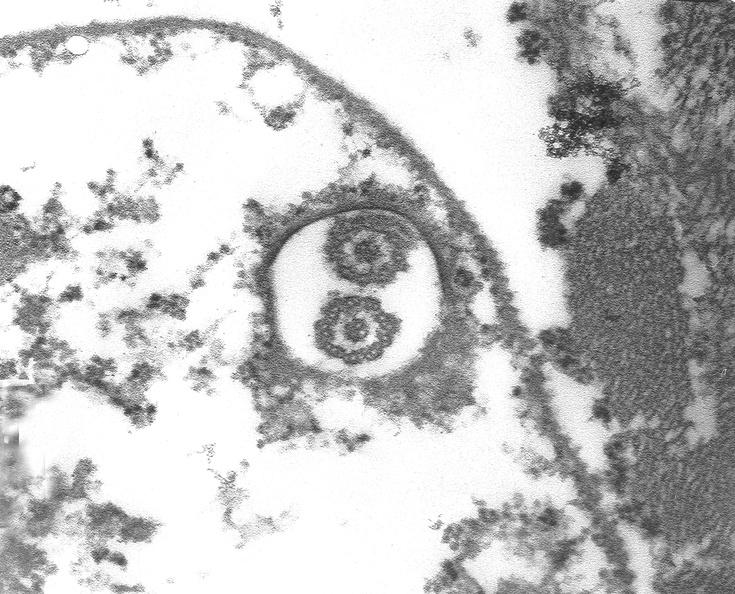where is this?
Answer the question using a single word or phrase. Heart 